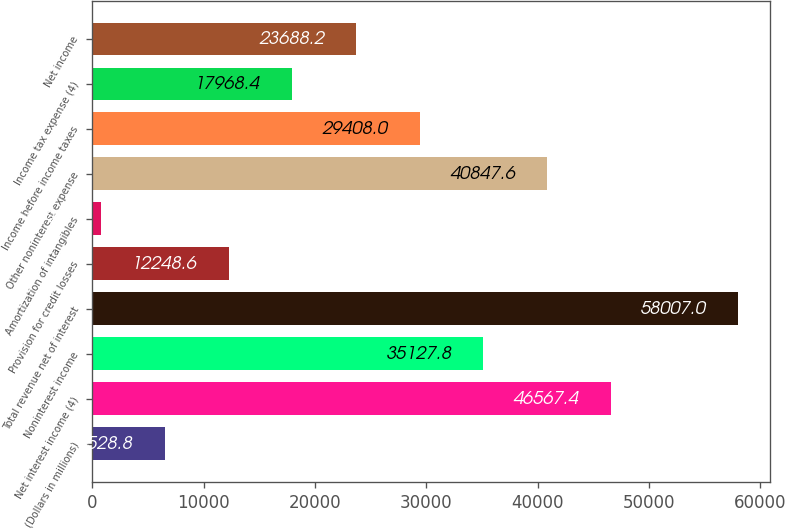<chart> <loc_0><loc_0><loc_500><loc_500><bar_chart><fcel>(Dollars in millions)<fcel>Net interest income (4)<fcel>Noninterest income<fcel>Total revenue net of interest<fcel>Provision for credit losses<fcel>Amortization of intangibles<fcel>Other noninterest expense<fcel>Income before income taxes<fcel>Income tax expense (4)<fcel>Net income<nl><fcel>6528.8<fcel>46567.4<fcel>35127.8<fcel>58007<fcel>12248.6<fcel>809<fcel>40847.6<fcel>29408<fcel>17968.4<fcel>23688.2<nl></chart> 